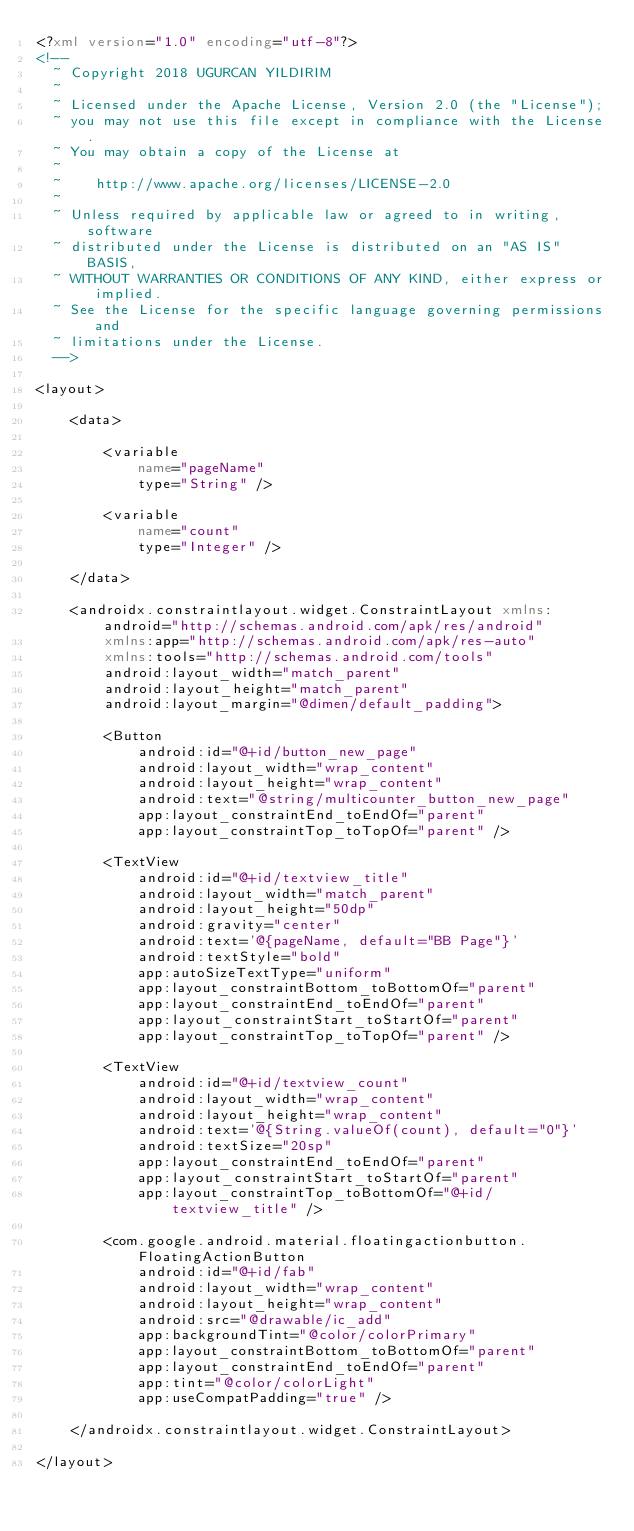<code> <loc_0><loc_0><loc_500><loc_500><_XML_><?xml version="1.0" encoding="utf-8"?>
<!--
  ~ Copyright 2018 UGURCAN YILDIRIM
  ~
  ~ Licensed under the Apache License, Version 2.0 (the "License");
  ~ you may not use this file except in compliance with the License.
  ~ You may obtain a copy of the License at
  ~
  ~    http://www.apache.org/licenses/LICENSE-2.0
  ~
  ~ Unless required by applicable law or agreed to in writing, software
  ~ distributed under the License is distributed on an "AS IS" BASIS,
  ~ WITHOUT WARRANTIES OR CONDITIONS OF ANY KIND, either express or implied.
  ~ See the License for the specific language governing permissions and
  ~ limitations under the License.
  -->

<layout>

    <data>

        <variable
            name="pageName"
            type="String" />

        <variable
            name="count"
            type="Integer" />

    </data>

    <androidx.constraintlayout.widget.ConstraintLayout xmlns:android="http://schemas.android.com/apk/res/android"
        xmlns:app="http://schemas.android.com/apk/res-auto"
        xmlns:tools="http://schemas.android.com/tools"
        android:layout_width="match_parent"
        android:layout_height="match_parent"
        android:layout_margin="@dimen/default_padding">

        <Button
            android:id="@+id/button_new_page"
            android:layout_width="wrap_content"
            android:layout_height="wrap_content"
            android:text="@string/multicounter_button_new_page"
            app:layout_constraintEnd_toEndOf="parent"
            app:layout_constraintTop_toTopOf="parent" />

        <TextView
            android:id="@+id/textview_title"
            android:layout_width="match_parent"
            android:layout_height="50dp"
            android:gravity="center"
            android:text='@{pageName, default="BB Page"}'
            android:textStyle="bold"
            app:autoSizeTextType="uniform"
            app:layout_constraintBottom_toBottomOf="parent"
            app:layout_constraintEnd_toEndOf="parent"
            app:layout_constraintStart_toStartOf="parent"
            app:layout_constraintTop_toTopOf="parent" />

        <TextView
            android:id="@+id/textview_count"
            android:layout_width="wrap_content"
            android:layout_height="wrap_content"
            android:text='@{String.valueOf(count), default="0"}'
            android:textSize="20sp"
            app:layout_constraintEnd_toEndOf="parent"
            app:layout_constraintStart_toStartOf="parent"
            app:layout_constraintTop_toBottomOf="@+id/textview_title" />

        <com.google.android.material.floatingactionbutton.FloatingActionButton
            android:id="@+id/fab"
            android:layout_width="wrap_content"
            android:layout_height="wrap_content"
            android:src="@drawable/ic_add"
            app:backgroundTint="@color/colorPrimary"
            app:layout_constraintBottom_toBottomOf="parent"
            app:layout_constraintEnd_toEndOf="parent"
            app:tint="@color/colorLight"
            app:useCompatPadding="true" />

    </androidx.constraintlayout.widget.ConstraintLayout>

</layout></code> 